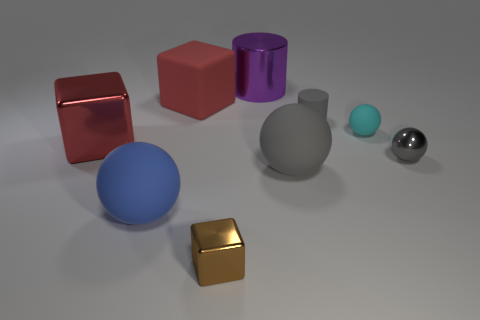Subtract all cubes. How many objects are left? 6 Subtract all brown cubes. Subtract all gray metal things. How many objects are left? 7 Add 7 purple shiny things. How many purple shiny things are left? 8 Add 1 gray rubber balls. How many gray rubber balls exist? 2 Subtract 0 green balls. How many objects are left? 9 